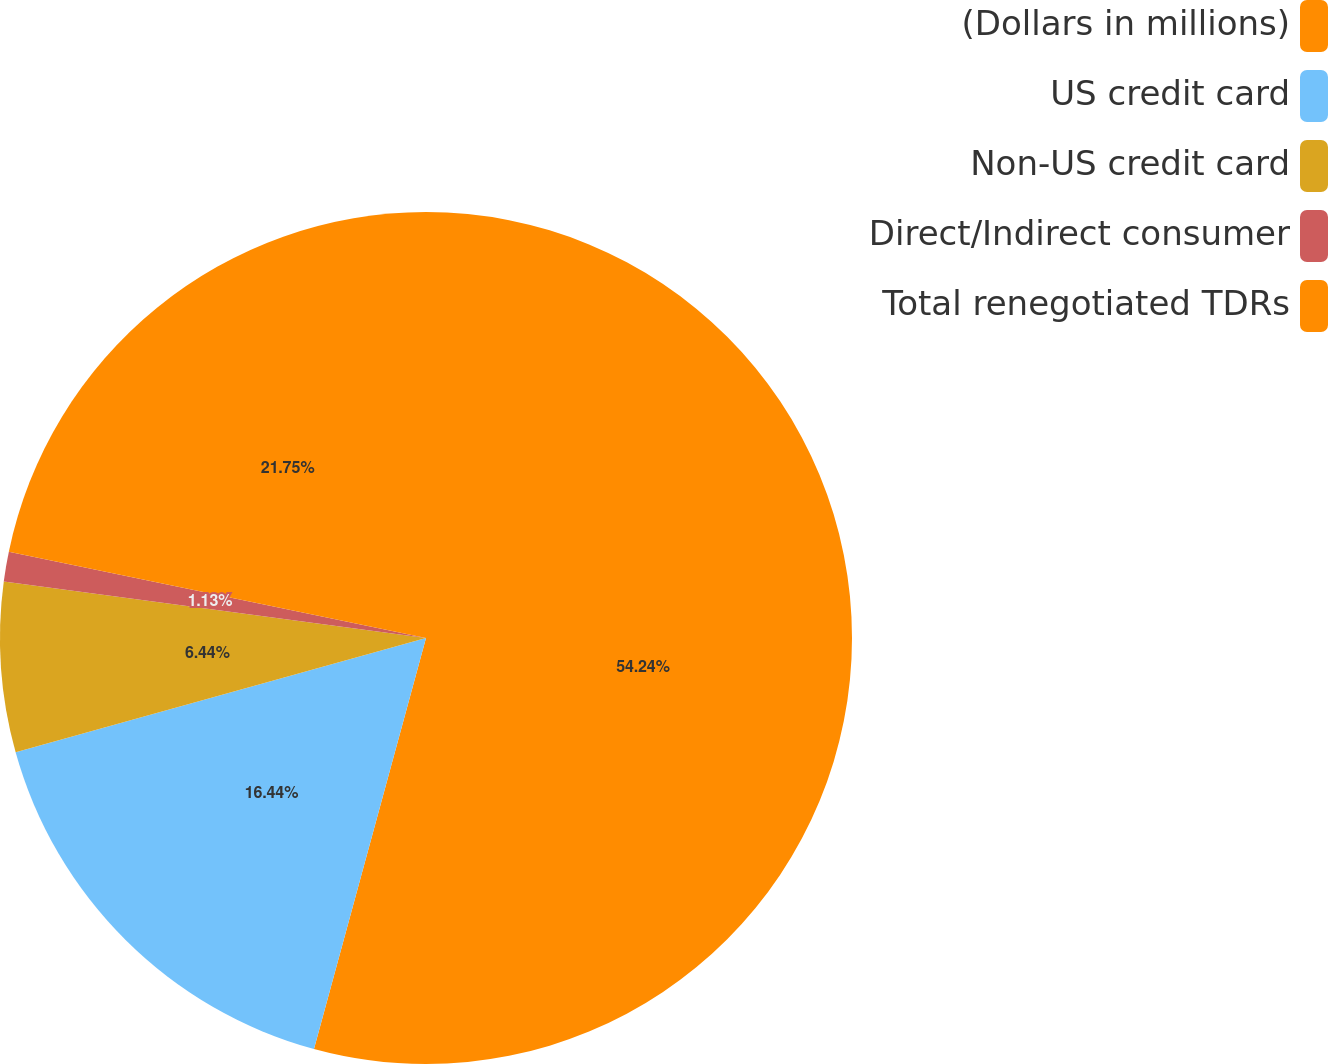<chart> <loc_0><loc_0><loc_500><loc_500><pie_chart><fcel>(Dollars in millions)<fcel>US credit card<fcel>Non-US credit card<fcel>Direct/Indirect consumer<fcel>Total renegotiated TDRs<nl><fcel>54.23%<fcel>16.44%<fcel>6.44%<fcel>1.13%<fcel>21.75%<nl></chart> 